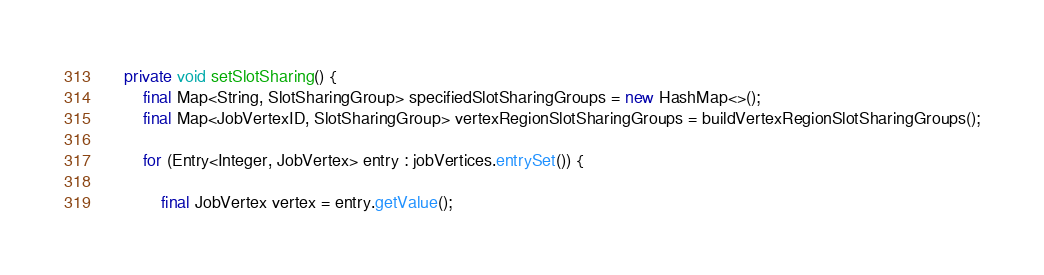<code> <loc_0><loc_0><loc_500><loc_500><_Java_>
	private void setSlotSharing() {
		final Map<String, SlotSharingGroup> specifiedSlotSharingGroups = new HashMap<>();
		final Map<JobVertexID, SlotSharingGroup> vertexRegionSlotSharingGroups = buildVertexRegionSlotSharingGroups();

		for (Entry<Integer, JobVertex> entry : jobVertices.entrySet()) {

			final JobVertex vertex = entry.getValue();</code> 